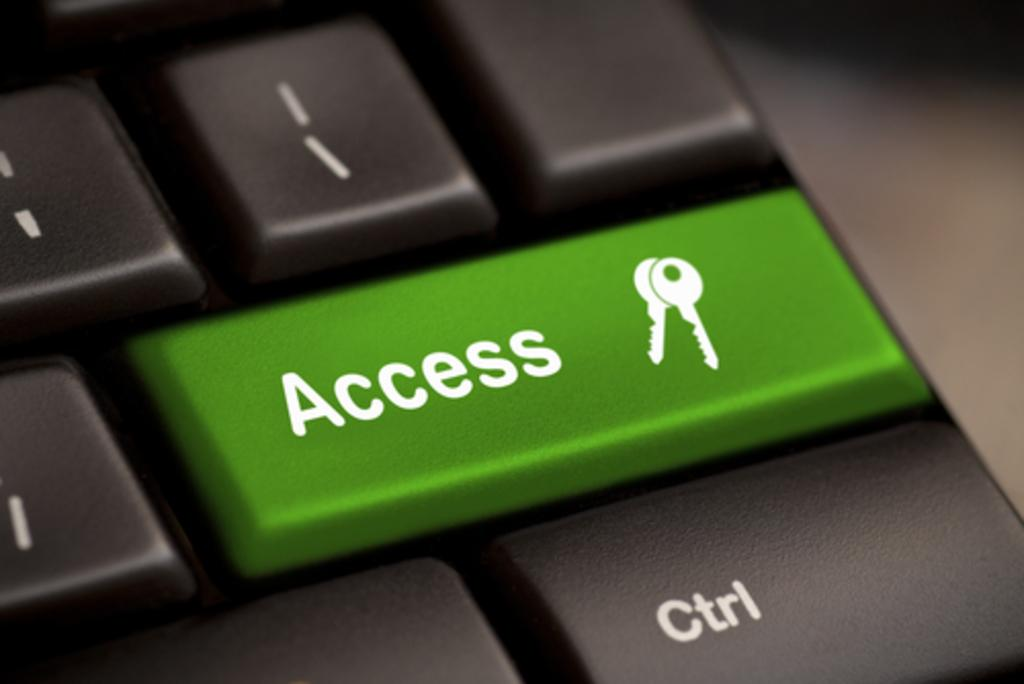Provide a one-sentence caption for the provided image. Large green access keyboard button with a key on it. 